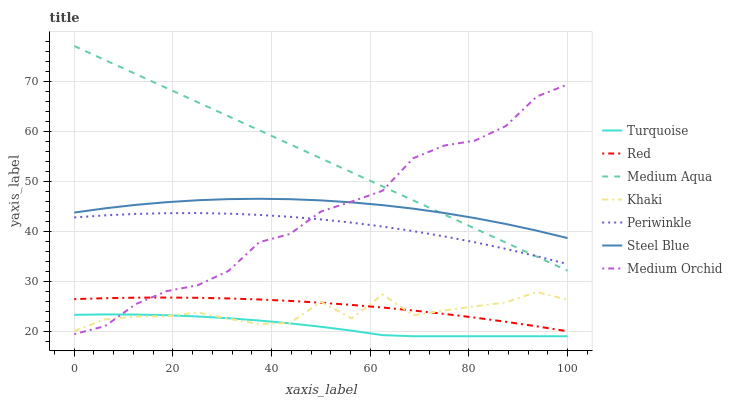Does Turquoise have the minimum area under the curve?
Answer yes or no. Yes. Does Medium Aqua have the maximum area under the curve?
Answer yes or no. Yes. Does Khaki have the minimum area under the curve?
Answer yes or no. No. Does Khaki have the maximum area under the curve?
Answer yes or no. No. Is Medium Aqua the smoothest?
Answer yes or no. Yes. Is Khaki the roughest?
Answer yes or no. Yes. Is Medium Orchid the smoothest?
Answer yes or no. No. Is Medium Orchid the roughest?
Answer yes or no. No. Does Khaki have the lowest value?
Answer yes or no. No. Does Medium Aqua have the highest value?
Answer yes or no. Yes. Does Khaki have the highest value?
Answer yes or no. No. Is Turquoise less than Red?
Answer yes or no. Yes. Is Periwinkle greater than Khaki?
Answer yes or no. Yes. Does Medium Orchid intersect Turquoise?
Answer yes or no. Yes. Is Medium Orchid less than Turquoise?
Answer yes or no. No. Is Medium Orchid greater than Turquoise?
Answer yes or no. No. Does Turquoise intersect Red?
Answer yes or no. No. 